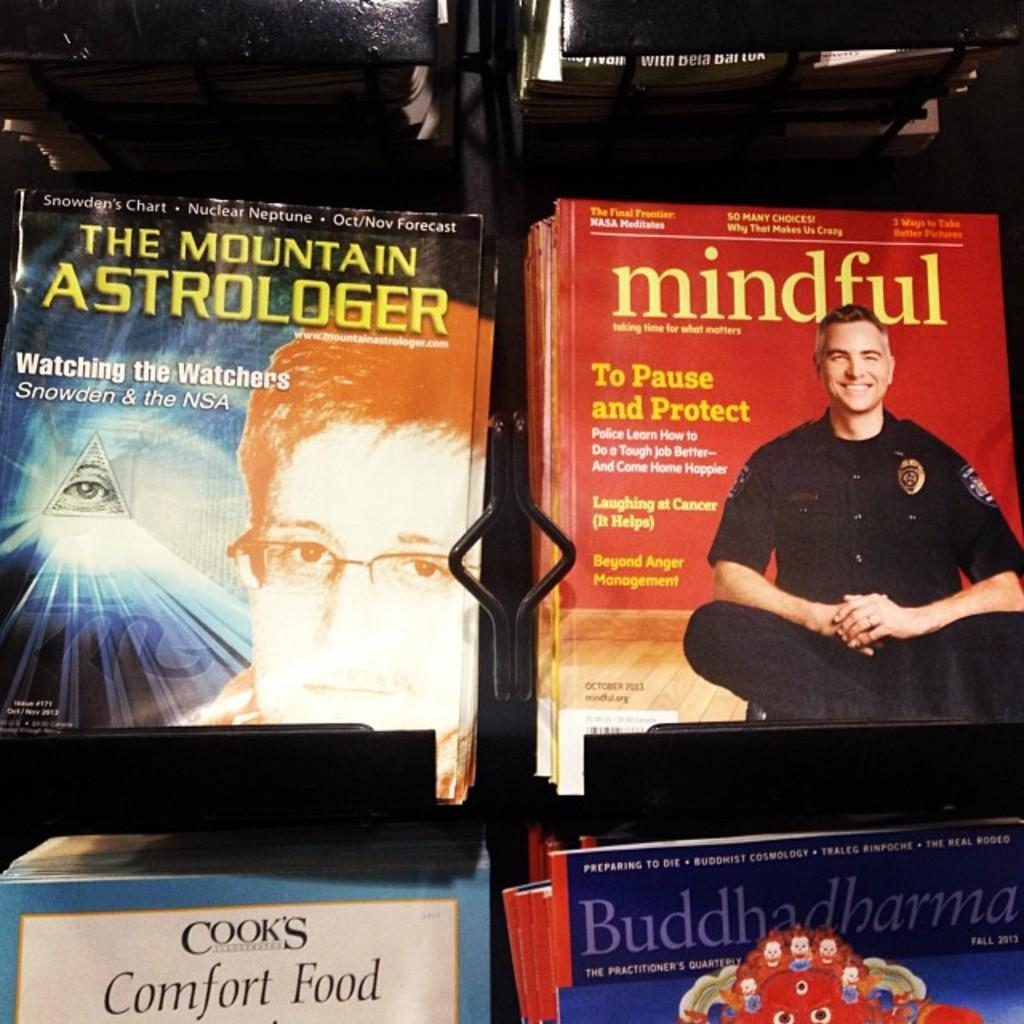<image>
Summarize the visual content of the image. a book has the word mindful on the cover 